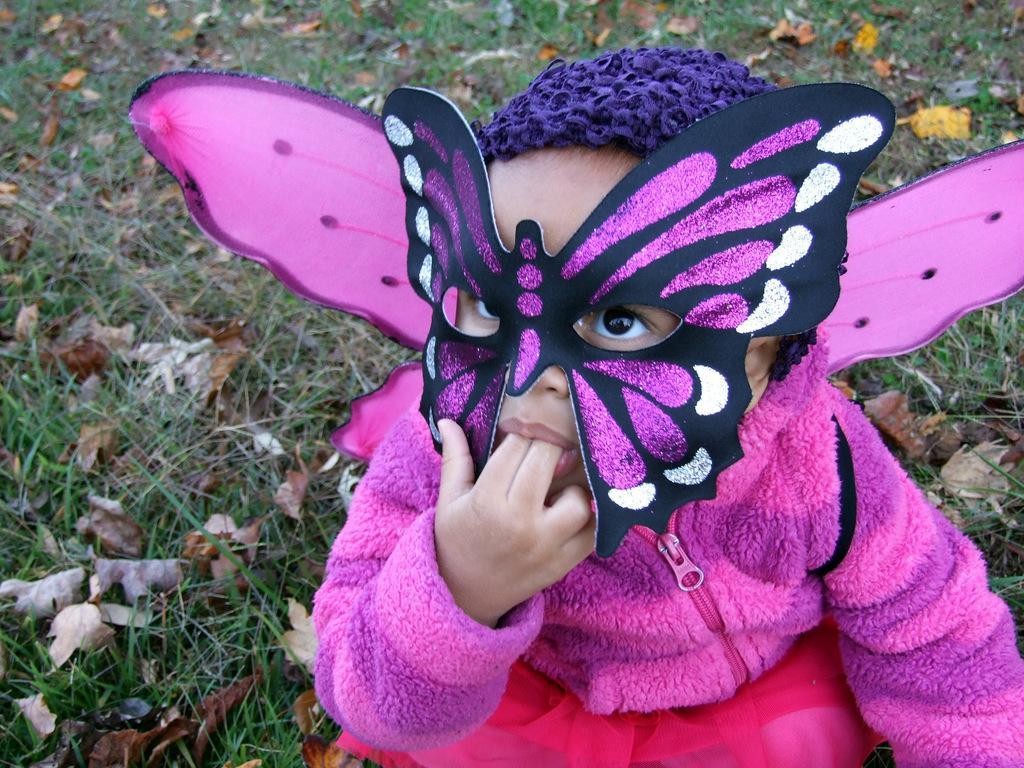In one or two sentences, can you explain what this image depicts? In this picture, we can see a child with a mask, and we can see the ground with grass, and dry leaves. 